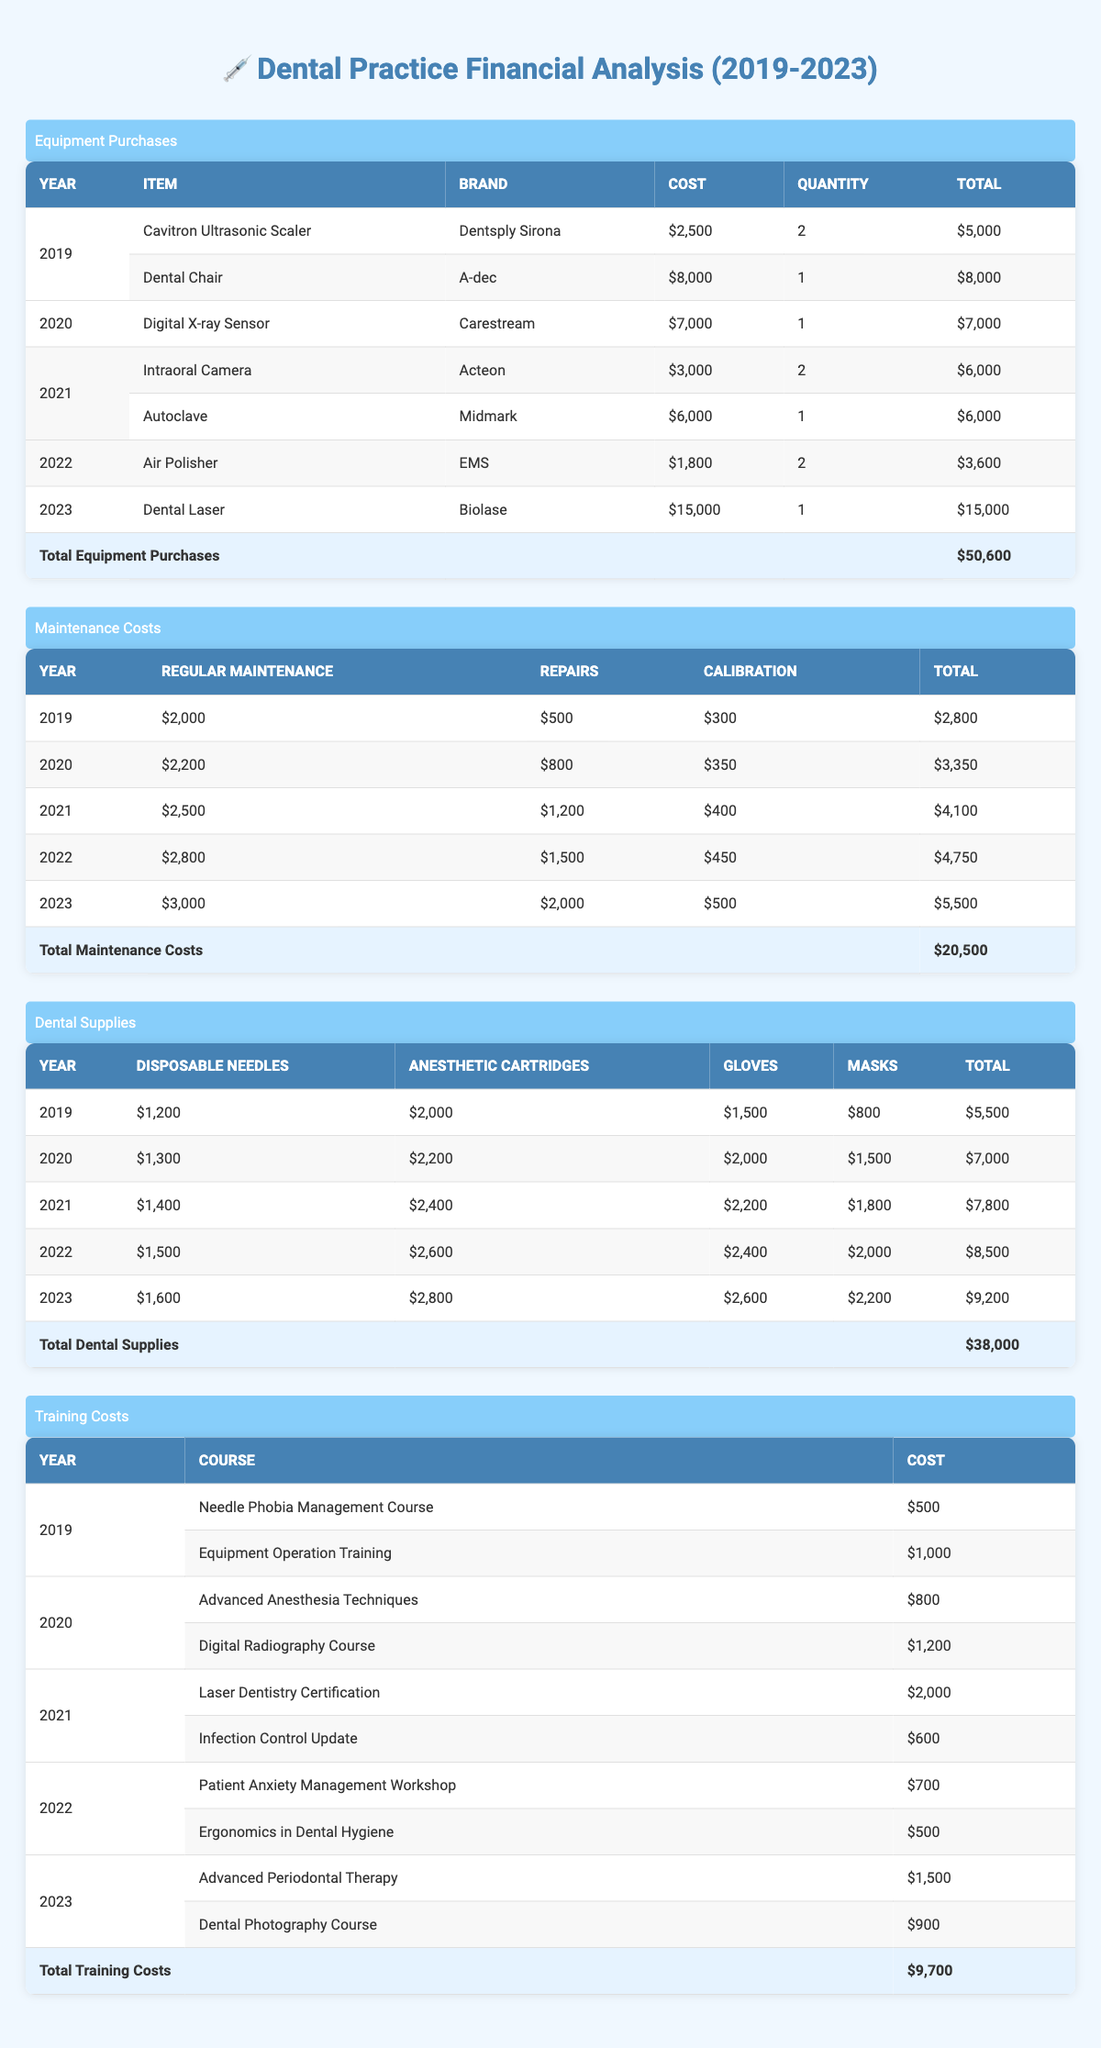What was the total cost of dental equipment purchases in 2022? According to the table, in 2022, the only item purchased was an Air Polisher for $1,800 with a quantity of 2, leading to a total of $3,600.
Answer: 3,600 What was the highest single equipment purchase value from 2019 to 2023? The highest single equipment purchase occurred in 2023 with a Dental Laser costing $15,000, which is greater than any single item from the previous years.
Answer: 15,000 Did the total maintenance costs increase from 2019 to 2023? Analyzing the yearly totals, the maintenance costs were $2,800 in 2019 and increased each year to reach $5,500 in 2023, confirming an increase.
Answer: Yes What was the average cost for dental supplies in 2021? The total cost for dental supplies in 2021 was $7,800. There are four supply categories (disposable needles, anesthetic cartridges, gloves, and masks), thus, averaging would be 7,800 / 4 = 1,950.
Answer: 1,950 What was the total training cost for the years 2020 and 2021 combined? From the table, the total training costs in 2020 were $2,000 (combined from both courses) and $2,600 in 2021. Adding these together, we get 2,000 + 2,600 = 4,600.
Answer: 4,600 Which year had the highest regular maintenance cost? Reviewing the maintenance costs, the highest regular maintenance cost was $3,000 in 2023, which exceeds all previous years' costs.
Answer: 3,000 Was there a year without any repairs reported in maintenance costs? The data shows repair costs for each year from 2019 to 2023, confirming that there was no year without reported repairs.
Answer: No What is the total cost of dental supplies in 2020? In 2020, adding the costs of disposable needles ($1,300), anesthetic cartridges ($2,200), gloves ($2,000), and masks ($1,500) gives a total of $7,000.
Answer: 7,000 What is the difference in total training costs between 2019 and 2023? The total training costs for 2019 sum to $1,500, and for 2023 they sum to $2,400. The difference is 2,400 - 1,500 = 900.
Answer: 900 How much did the dental practice spend on regular maintenance over the five years? Summing the regular maintenance costs: $2,000 (2019) + $2,200 (2020) + $2,500 (2021) + $2,800 (2022) + $3,000 (2023) results in a total of $12,500 across all five years.
Answer: 12,500 